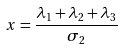Convert formula to latex. <formula><loc_0><loc_0><loc_500><loc_500>x = \frac { \lambda _ { 1 } + \lambda _ { 2 } + \lambda _ { 3 } } { \sigma _ { 2 } }</formula> 